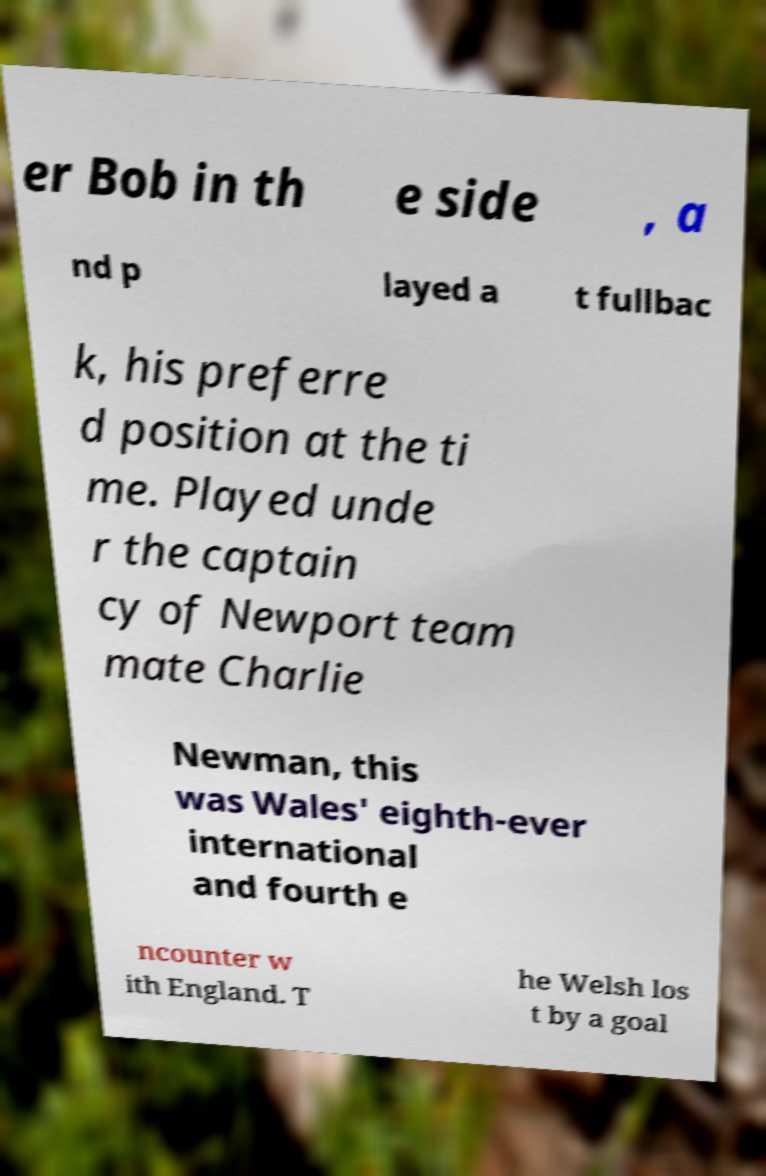There's text embedded in this image that I need extracted. Can you transcribe it verbatim? er Bob in th e side , a nd p layed a t fullbac k, his preferre d position at the ti me. Played unde r the captain cy of Newport team mate Charlie Newman, this was Wales' eighth-ever international and fourth e ncounter w ith England. T he Welsh los t by a goal 